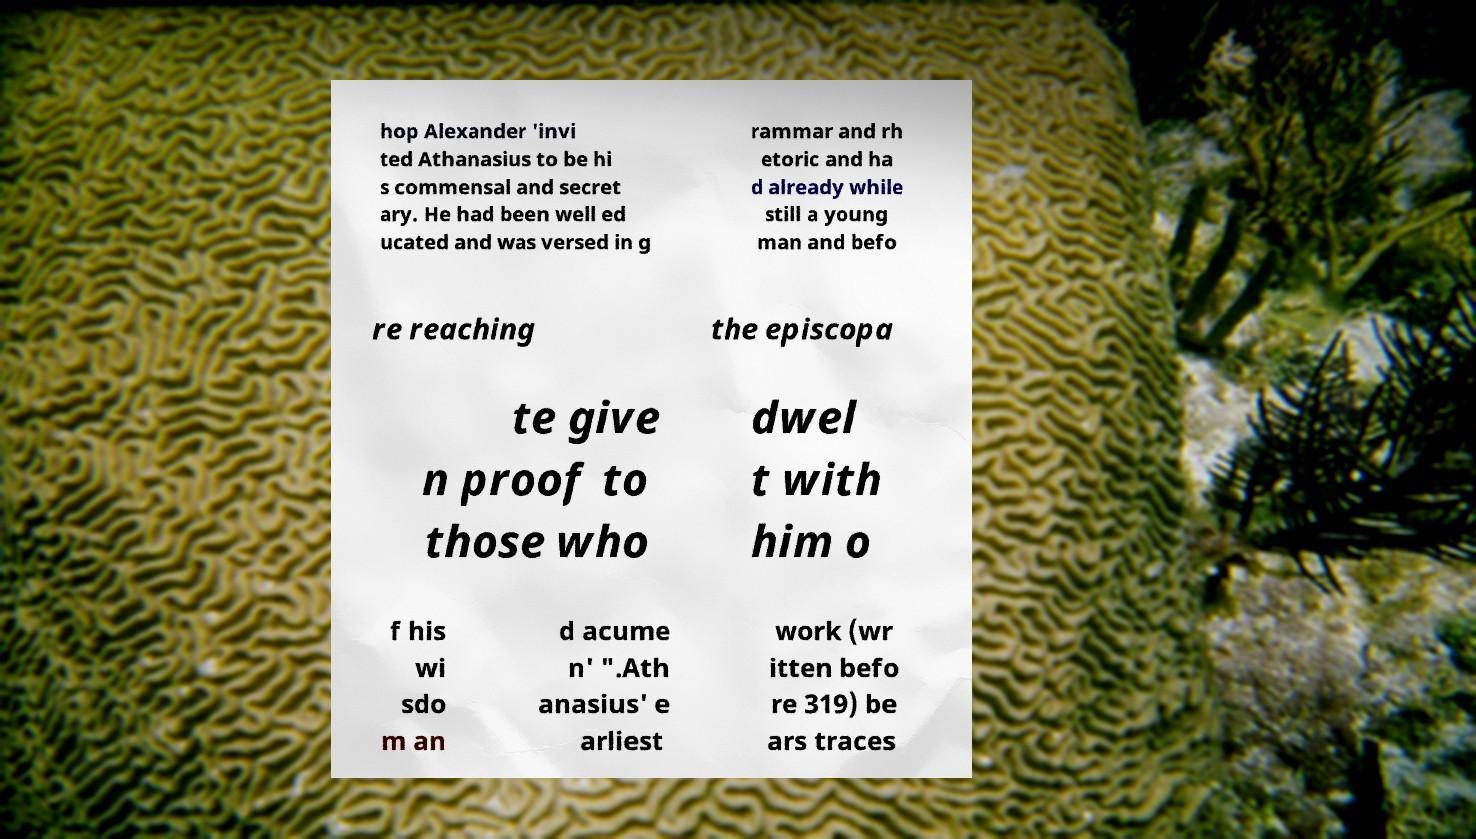Can you read and provide the text displayed in the image?This photo seems to have some interesting text. Can you extract and type it out for me? hop Alexander 'invi ted Athanasius to be hi s commensal and secret ary. He had been well ed ucated and was versed in g rammar and rh etoric and ha d already while still a young man and befo re reaching the episcopa te give n proof to those who dwel t with him o f his wi sdo m an d acume n' ".Ath anasius' e arliest work (wr itten befo re 319) be ars traces 